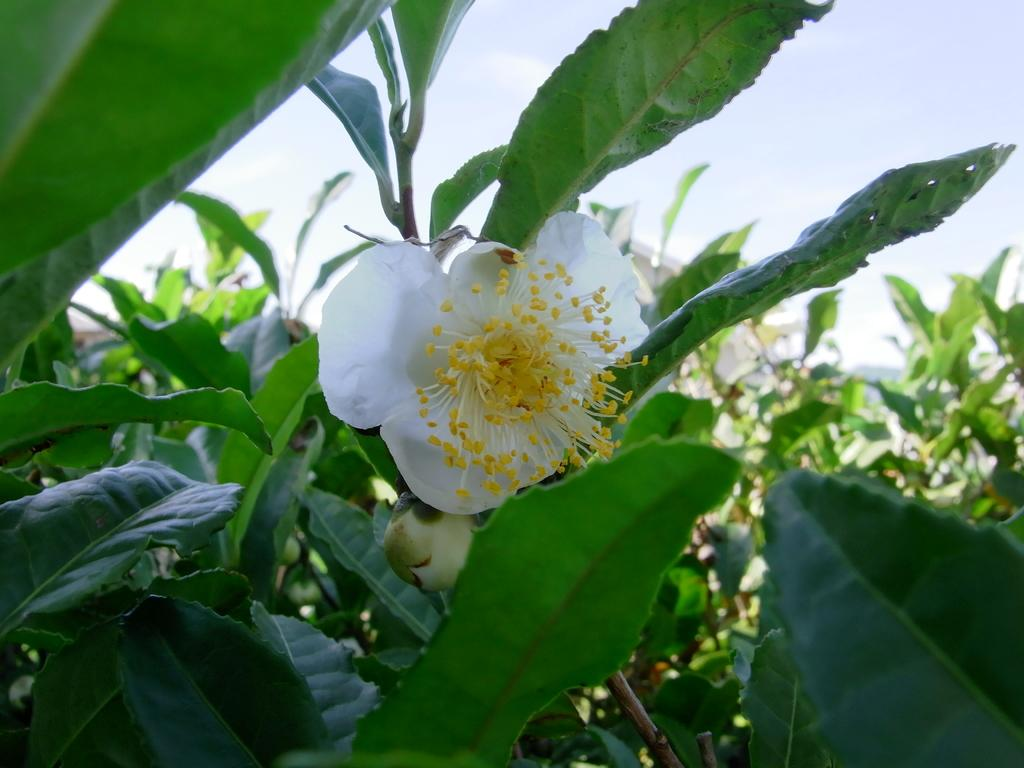What type of vegetation can be seen in the image? There are green color leaves in the image. What is the color of the flower in the image? The flower in the image is white. Where is the flower located in relation to the leaves? The flower is located in the center of the image. What type of nerve is visible in the image? There is no nerve visible in the image; it features green leaves and a white flower. What type of prose can be read in the image? There is no prose present in the image; it is a photograph of leaves and a flower. 